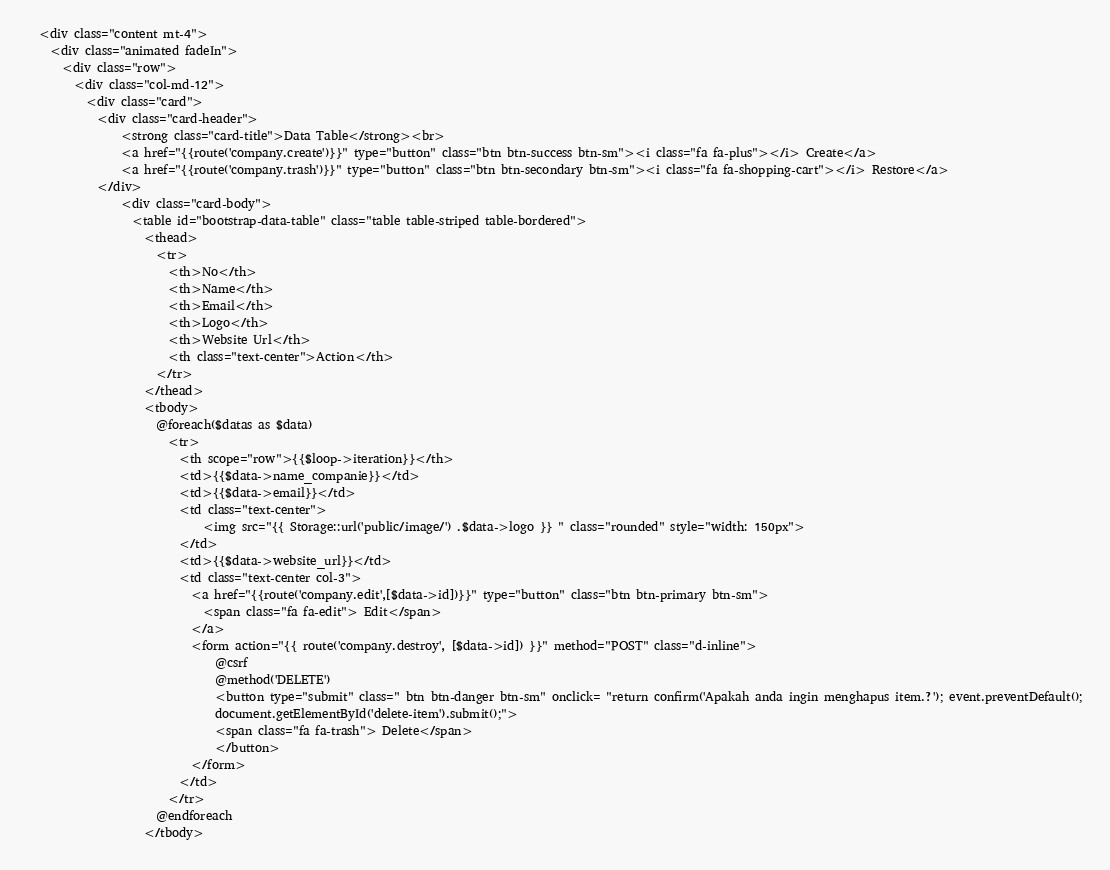Convert code to text. <code><loc_0><loc_0><loc_500><loc_500><_PHP_>  <div class="content mt-4">
    <div class="animated fadeIn">
      <div class="row">
        <div class="col-md-12">
          <div class="card">
            <div class="card-header">
                <strong class="card-title">Data Table</strong><br>
                <a href="{{route('company.create')}}" type="button" class="btn btn-success btn-sm"><i class="fa fa-plus"></i> Create</a>
                <a href="{{route('company.trash')}}" type="button" class="btn btn-secondary btn-sm"><i class="fa fa-shopping-cart"></i> Restore</a>
            </div>
                <div class="card-body">
                  <table id="bootstrap-data-table" class="table table-striped table-bordered">
                    <thead>
                      <tr>
                        <th>No</th>
                        <th>Name</th>
                        <th>Email</th>
                        <th>Logo</th>
                        <th>Website Url</th>
                        <th class="text-center">Action</th>
                      </tr>
                    </thead>
                    <tbody>
                      @foreach($datas as $data)
                        <tr>
                          <th scope="row">{{$loop->iteration}}</th>
                          <td>{{$data->name_companie}}</td>
                          <td>{{$data->email}}</td>
                          <td class="text-center">
                              <img src="{{ Storage::url('public/image/') .$data->logo }} " class="rounded" style="width: 150px">
                          </td>
                          <td>{{$data->website_url}}</td>
                          <td class="text-center col-3">
                            <a href="{{route('company.edit',[$data->id])}}" type="button" class="btn btn-primary btn-sm">
                              <span class="fa fa-edit"> Edit</span>
                            </a>
                            <form action="{{ route('company.destroy', [$data->id]) }}" method="POST" class="d-inline">
                                @csrf
                                @method('DELETE')
                                <button type="submit" class=" btn btn-danger btn-sm" onclick= "return confirm('Apakah anda ingin menghapus item.?'); event.preventDefault();
                                document.getElementById('delete-item').submit();">
                                <span class="fa fa-trash"> Delete</span>
                                </button>
                            </form>
                          </td>
                        </tr>
                      @endforeach
                    </tbody></code> 